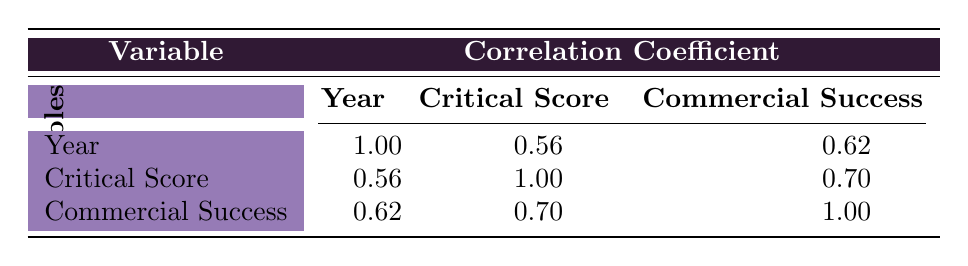What is the correlation coefficient between critical score and commercial success? The correlation coefficient between critical score and commercial success is clearly stated in the table, which shows a value of 0.70.
Answer: 0.70 Which album has the highest critical score? Looking at the critical scores listed, "OK Computer" has the highest score at 96.
Answer: OK Computer What is the average commercial success for albums released after 1990? The albums released after 1990 are "Sailing the Seas of Cheese," "Random Access Memories," "In Rainbows," and "Kid A." Their commercial successes are 1500000, 3500000, 3000000, and 900000 respectively. The total is 1500000 + 3500000 + 3000000 + 900000 = 8900000. There are 4 albums, so the average is 8900000 / 4 = 2225000.
Answer: 2225000 Is there a negative correlation between year of release and critical score? The table shows a correlation coefficient of 0.56 between year and critical score, which indicates a positive correlation, meaning as the years increase, the critical scores tend to increase. Hence, there is no negative correlation.
Answer: No In which year was the album with the lowest commercial success released? Assessing the commercial success figures, "F#A#∞" released in 1997 has the lowest commercial success at 200000. Thus, the year it was released is 1997.
Answer: 1997 What is the difference in critical scores between "The Rise and Fall of Ziggy Stardust and the Spiders from Mars" and "Kid A"? The critical score for "The Rise and Fall of Ziggy Stardust and the Spiders from Mars" is 90, while "Kid A" has a critical score of 94. The difference is calculated by subtracting the lower score from the higher: 94 - 90 = 4.
Answer: 4 Are there any albums with a commercial success above 2 million that also have a critical score lower than 90? The table shows two albums with commercial success above 2 million: "OK Computer" (3,000,000, critical score 96) and "Random Access Memories" (3,500,000, critical score 92). Both of these have critical scores of 90 or above, meaning there are no albums meeting these criteria.
Answer: No What is the median critical score of the listed albums? To find the median critical score, first, we need to list the critical scores in order: 78, 85, 86, 87, 90, 90, 92, 94, 95, 96. With 10 data points, the median is the average of the 5th and 6th values: (90 + 90) / 2 = 90.
Answer: 90 